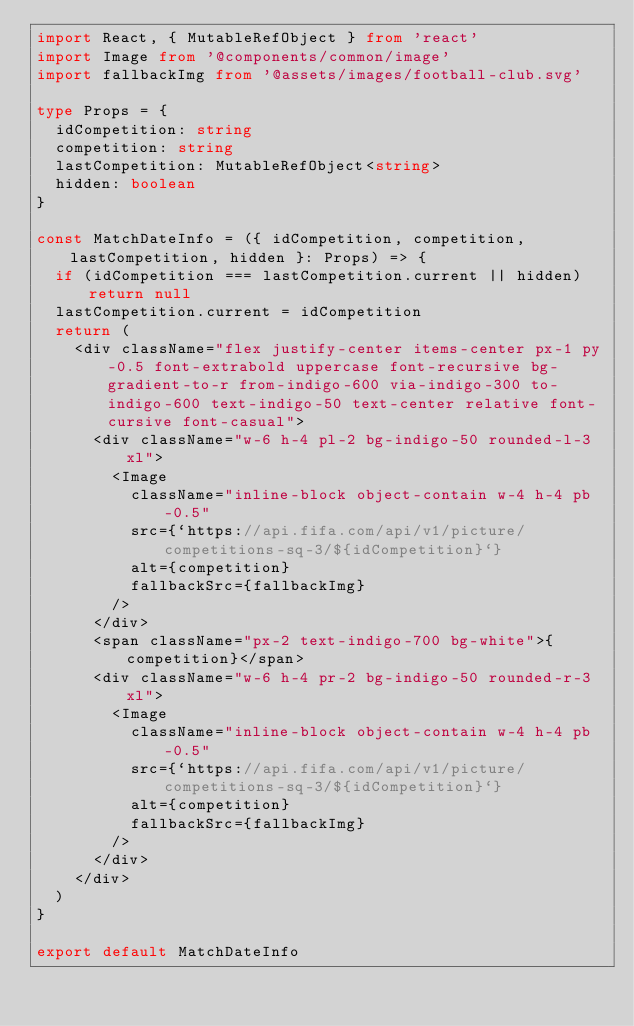<code> <loc_0><loc_0><loc_500><loc_500><_TypeScript_>import React, { MutableRefObject } from 'react'
import Image from '@components/common/image'
import fallbackImg from '@assets/images/football-club.svg'

type Props = {
  idCompetition: string
  competition: string
  lastCompetition: MutableRefObject<string>
  hidden: boolean
}

const MatchDateInfo = ({ idCompetition, competition, lastCompetition, hidden }: Props) => {
  if (idCompetition === lastCompetition.current || hidden) return null
  lastCompetition.current = idCompetition
  return (
    <div className="flex justify-center items-center px-1 py-0.5 font-extrabold uppercase font-recursive bg-gradient-to-r from-indigo-600 via-indigo-300 to-indigo-600 text-indigo-50 text-center relative font-cursive font-casual">
      <div className="w-6 h-4 pl-2 bg-indigo-50 rounded-l-3xl">
        <Image
          className="inline-block object-contain w-4 h-4 pb-0.5"
          src={`https://api.fifa.com/api/v1/picture/competitions-sq-3/${idCompetition}`}
          alt={competition}
          fallbackSrc={fallbackImg}
        />
      </div>
      <span className="px-2 text-indigo-700 bg-white">{competition}</span>
      <div className="w-6 h-4 pr-2 bg-indigo-50 rounded-r-3xl">
        <Image
          className="inline-block object-contain w-4 h-4 pb-0.5"
          src={`https://api.fifa.com/api/v1/picture/competitions-sq-3/${idCompetition}`}
          alt={competition}
          fallbackSrc={fallbackImg}
        />
      </div>
    </div>
  )
}

export default MatchDateInfo
</code> 